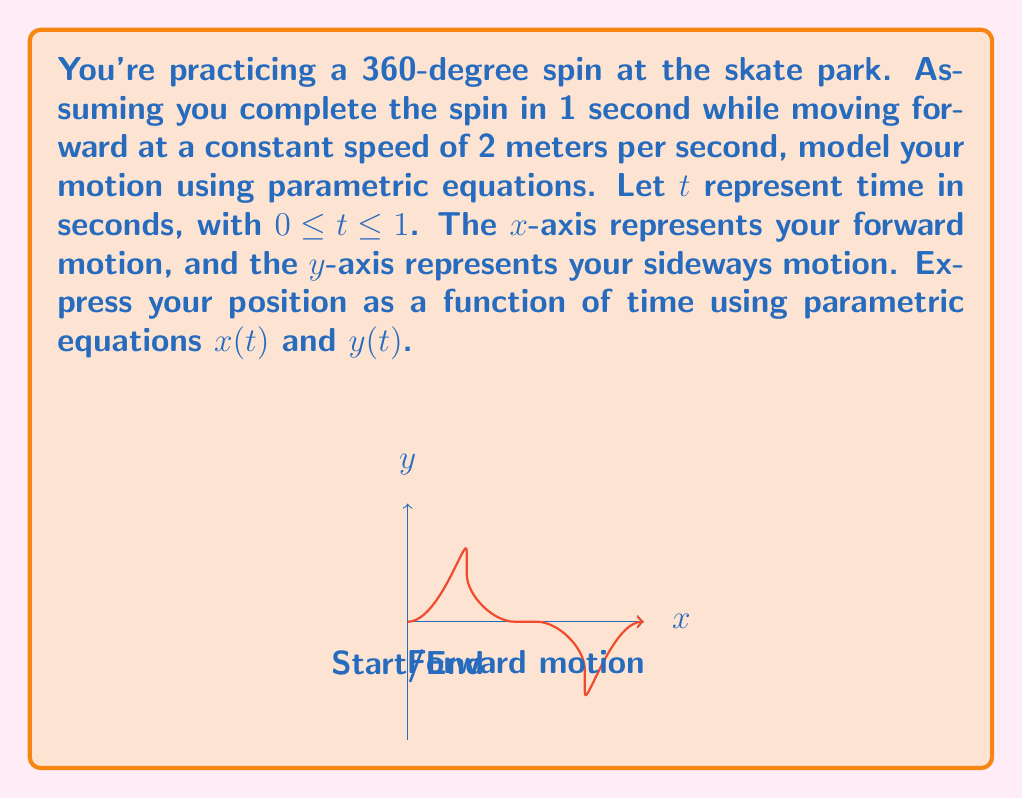Show me your answer to this math problem. Let's approach this step-by-step:

1) First, consider the forward motion (along the $x$-axis):
   - You're moving at a constant speed of 2 m/s for 1 second.
   - This means $x(t) = 2t$ meters.

2) Now, for the spinning motion (in the $y$ direction):
   - A full 360-degree spin can be modeled using a sine function.
   - The sine function completes one full cycle over $2\pi$ radians.
   - We need to scale and shift this to fit our scenario.

3) To model the spin:
   - Use $\sin(2\pi t)$ to complete one full cycle over 1 second.
   - Multiply by a radius to give the spin some width. Let's use 0.5 meters.
   - So, $y(t) = 0.5 \sin(2\pi t)$ meters.

4) Combining these, we get the parametric equations:
   $$x(t) = 2t$$
   $$y(t) = 0.5 \sin(2\pi t)$$

5) These equations are valid for $0 \leq t \leq 1$, representing the 1-second duration of the spin.
Answer: $x(t) = 2t$, $y(t) = 0.5 \sin(2\pi t)$, $0 \leq t \leq 1$ 